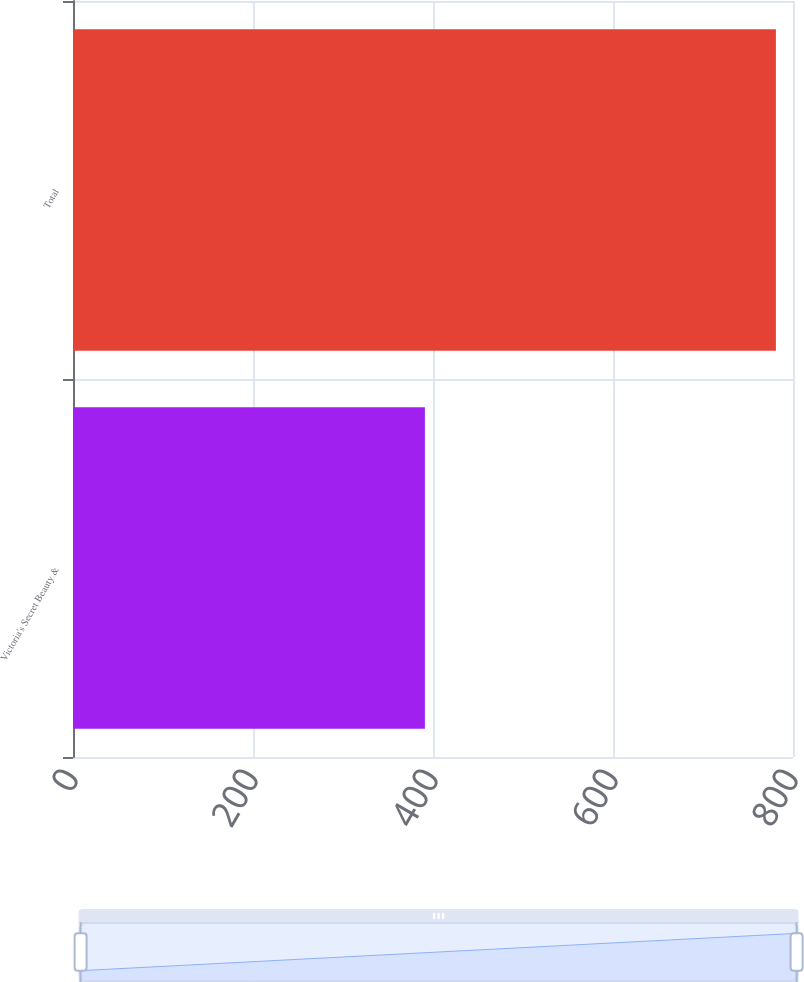<chart> <loc_0><loc_0><loc_500><loc_500><bar_chart><fcel>Victoria's Secret Beauty &<fcel>Total<nl><fcel>391<fcel>781<nl></chart> 